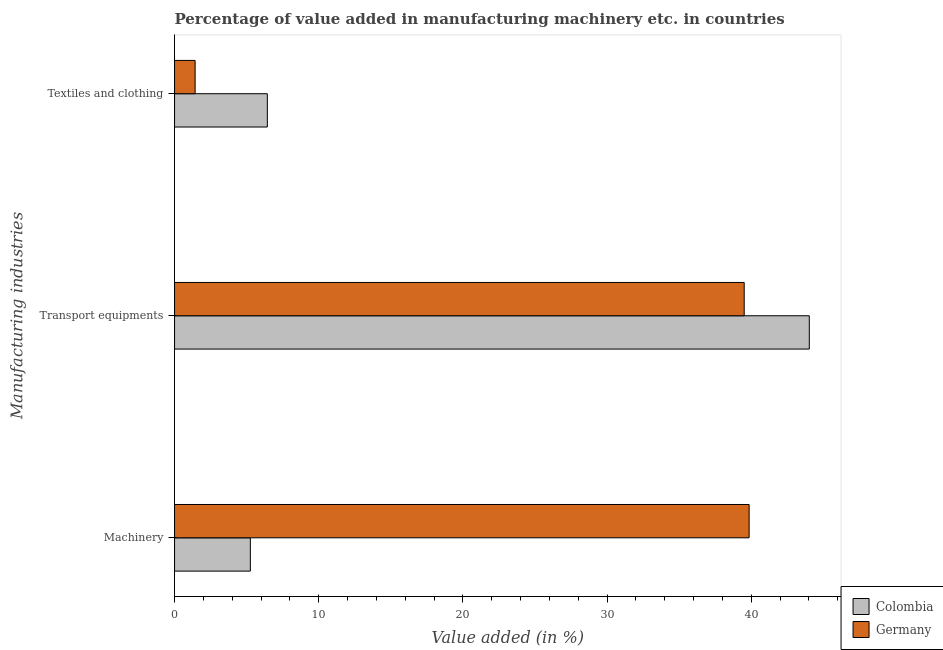How many different coloured bars are there?
Offer a terse response. 2. Are the number of bars per tick equal to the number of legend labels?
Offer a terse response. Yes. Are the number of bars on each tick of the Y-axis equal?
Your answer should be compact. Yes. How many bars are there on the 2nd tick from the bottom?
Ensure brevity in your answer.  2. What is the label of the 2nd group of bars from the top?
Keep it short and to the point. Transport equipments. What is the value added in manufacturing transport equipments in Germany?
Your response must be concise. 39.51. Across all countries, what is the maximum value added in manufacturing machinery?
Your response must be concise. 39.86. Across all countries, what is the minimum value added in manufacturing transport equipments?
Your answer should be compact. 39.51. In which country was the value added in manufacturing machinery minimum?
Your response must be concise. Colombia. What is the total value added in manufacturing textile and clothing in the graph?
Make the answer very short. 7.86. What is the difference between the value added in manufacturing textile and clothing in Colombia and that in Germany?
Ensure brevity in your answer.  5.01. What is the difference between the value added in manufacturing machinery in Germany and the value added in manufacturing textile and clothing in Colombia?
Make the answer very short. 33.42. What is the average value added in manufacturing textile and clothing per country?
Your answer should be compact. 3.93. What is the difference between the value added in manufacturing textile and clothing and value added in manufacturing machinery in Germany?
Keep it short and to the point. -38.43. What is the ratio of the value added in manufacturing textile and clothing in Colombia to that in Germany?
Provide a succinct answer. 4.51. Is the value added in manufacturing transport equipments in Colombia less than that in Germany?
Offer a terse response. No. Is the difference between the value added in manufacturing machinery in Colombia and Germany greater than the difference between the value added in manufacturing transport equipments in Colombia and Germany?
Provide a short and direct response. No. What is the difference between the highest and the second highest value added in manufacturing machinery?
Make the answer very short. 34.6. What is the difference between the highest and the lowest value added in manufacturing textile and clothing?
Ensure brevity in your answer.  5.01. In how many countries, is the value added in manufacturing machinery greater than the average value added in manufacturing machinery taken over all countries?
Offer a terse response. 1. What does the 2nd bar from the bottom in Transport equipments represents?
Provide a succinct answer. Germany. Is it the case that in every country, the sum of the value added in manufacturing machinery and value added in manufacturing transport equipments is greater than the value added in manufacturing textile and clothing?
Ensure brevity in your answer.  Yes. How many bars are there?
Make the answer very short. 6. Are all the bars in the graph horizontal?
Give a very brief answer. Yes. How many countries are there in the graph?
Provide a short and direct response. 2. What is the difference between two consecutive major ticks on the X-axis?
Your answer should be very brief. 10. What is the title of the graph?
Offer a terse response. Percentage of value added in manufacturing machinery etc. in countries. Does "Low income" appear as one of the legend labels in the graph?
Your answer should be very brief. No. What is the label or title of the X-axis?
Provide a short and direct response. Value added (in %). What is the label or title of the Y-axis?
Your answer should be very brief. Manufacturing industries. What is the Value added (in %) in Colombia in Machinery?
Provide a succinct answer. 5.26. What is the Value added (in %) in Germany in Machinery?
Ensure brevity in your answer.  39.86. What is the Value added (in %) of Colombia in Transport equipments?
Make the answer very short. 44.03. What is the Value added (in %) of Germany in Transport equipments?
Offer a very short reply. 39.51. What is the Value added (in %) of Colombia in Textiles and clothing?
Keep it short and to the point. 6.44. What is the Value added (in %) of Germany in Textiles and clothing?
Provide a short and direct response. 1.43. Across all Manufacturing industries, what is the maximum Value added (in %) in Colombia?
Provide a short and direct response. 44.03. Across all Manufacturing industries, what is the maximum Value added (in %) of Germany?
Provide a succinct answer. 39.86. Across all Manufacturing industries, what is the minimum Value added (in %) in Colombia?
Give a very brief answer. 5.26. Across all Manufacturing industries, what is the minimum Value added (in %) in Germany?
Offer a very short reply. 1.43. What is the total Value added (in %) in Colombia in the graph?
Your answer should be compact. 55.72. What is the total Value added (in %) in Germany in the graph?
Offer a terse response. 80.8. What is the difference between the Value added (in %) of Colombia in Machinery and that in Transport equipments?
Give a very brief answer. -38.77. What is the difference between the Value added (in %) of Germany in Machinery and that in Transport equipments?
Give a very brief answer. 0.34. What is the difference between the Value added (in %) in Colombia in Machinery and that in Textiles and clothing?
Keep it short and to the point. -1.18. What is the difference between the Value added (in %) in Germany in Machinery and that in Textiles and clothing?
Your response must be concise. 38.43. What is the difference between the Value added (in %) of Colombia in Transport equipments and that in Textiles and clothing?
Your answer should be compact. 37.59. What is the difference between the Value added (in %) of Germany in Transport equipments and that in Textiles and clothing?
Your answer should be compact. 38.09. What is the difference between the Value added (in %) of Colombia in Machinery and the Value added (in %) of Germany in Transport equipments?
Keep it short and to the point. -34.26. What is the difference between the Value added (in %) in Colombia in Machinery and the Value added (in %) in Germany in Textiles and clothing?
Your response must be concise. 3.83. What is the difference between the Value added (in %) in Colombia in Transport equipments and the Value added (in %) in Germany in Textiles and clothing?
Your answer should be very brief. 42.6. What is the average Value added (in %) in Colombia per Manufacturing industries?
Provide a short and direct response. 18.57. What is the average Value added (in %) in Germany per Manufacturing industries?
Offer a terse response. 26.93. What is the difference between the Value added (in %) of Colombia and Value added (in %) of Germany in Machinery?
Offer a terse response. -34.6. What is the difference between the Value added (in %) in Colombia and Value added (in %) in Germany in Transport equipments?
Provide a succinct answer. 4.52. What is the difference between the Value added (in %) in Colombia and Value added (in %) in Germany in Textiles and clothing?
Provide a short and direct response. 5.01. What is the ratio of the Value added (in %) in Colombia in Machinery to that in Transport equipments?
Offer a terse response. 0.12. What is the ratio of the Value added (in %) of Germany in Machinery to that in Transport equipments?
Your answer should be very brief. 1.01. What is the ratio of the Value added (in %) in Colombia in Machinery to that in Textiles and clothing?
Your response must be concise. 0.82. What is the ratio of the Value added (in %) in Germany in Machinery to that in Textiles and clothing?
Offer a terse response. 27.94. What is the ratio of the Value added (in %) of Colombia in Transport equipments to that in Textiles and clothing?
Your response must be concise. 6.84. What is the ratio of the Value added (in %) of Germany in Transport equipments to that in Textiles and clothing?
Provide a succinct answer. 27.7. What is the difference between the highest and the second highest Value added (in %) of Colombia?
Make the answer very short. 37.59. What is the difference between the highest and the second highest Value added (in %) in Germany?
Ensure brevity in your answer.  0.34. What is the difference between the highest and the lowest Value added (in %) of Colombia?
Give a very brief answer. 38.77. What is the difference between the highest and the lowest Value added (in %) in Germany?
Provide a succinct answer. 38.43. 